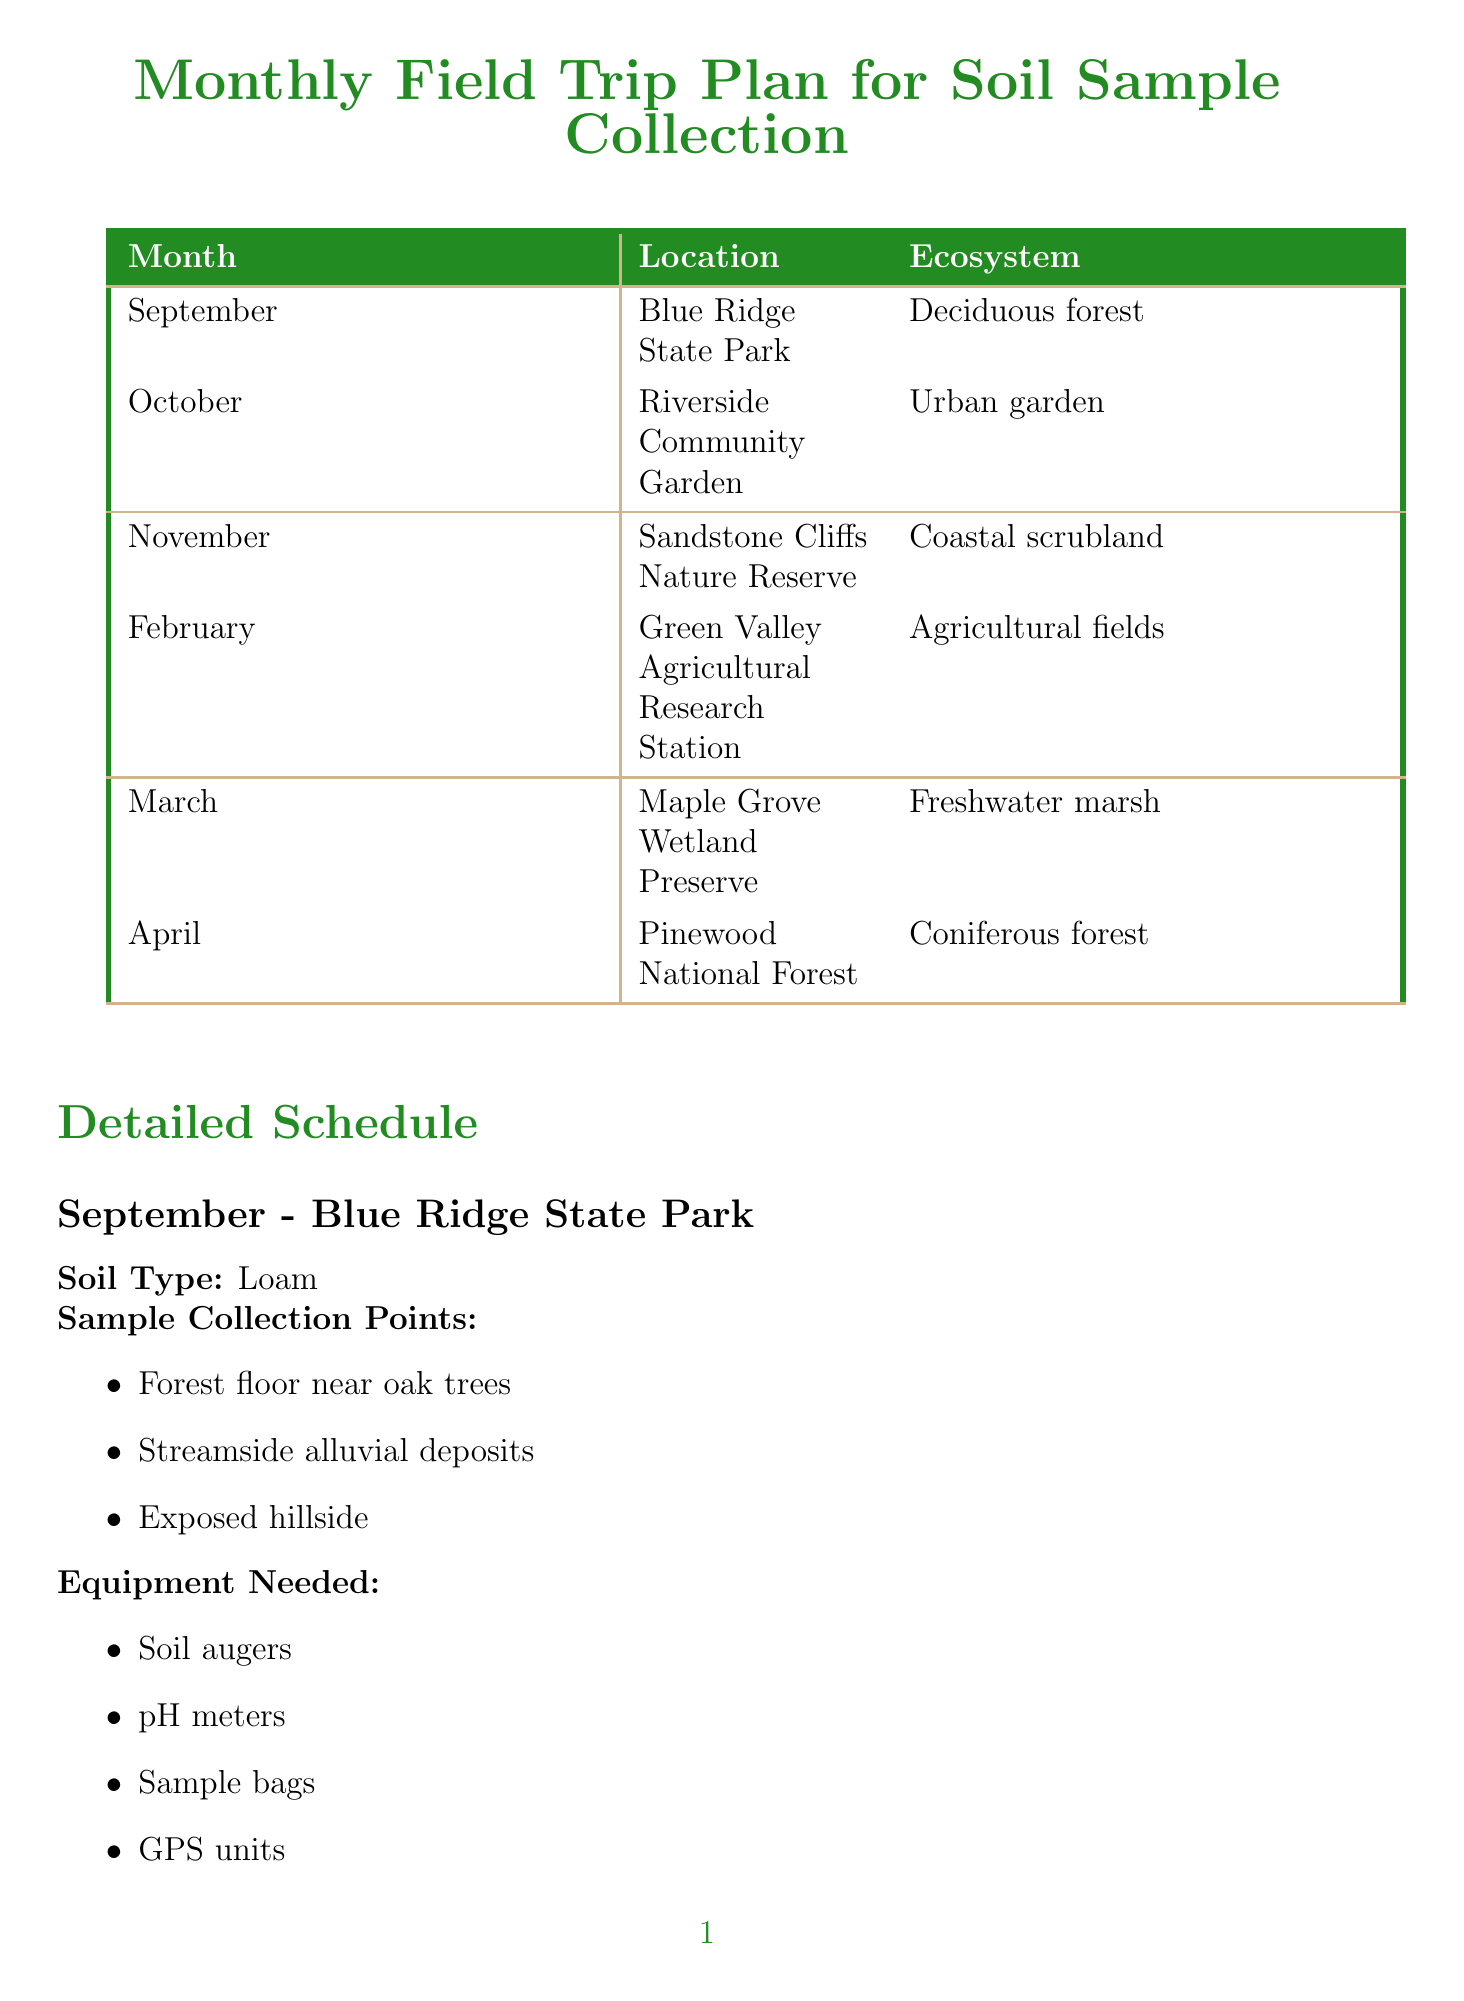What is the first field trip location? The first field trip in the schedule is listed for September at Blue Ridge State Park.
Answer: Blue Ridge State Park What type of soil is collected in October? In October, the soil type listed is clay-loam for the Riverside Community Garden.
Answer: Clay-loam How many sample collection points are there for the March field trip? The March field trip has three sample collection points listed for the Maple Grove Wetland Preserve.
Answer: 3 What is one equipment needed for the November trip? The November trip specifies core samplers as one piece of equipment needed for Sandstone Cliffs Nature Reserve.
Answer: Core samplers What is one learning objective for the April field trip? One learning objective for the April trip is to analyze soil acidity and its effects on nutrient availability in Pinewood National Forest.
Answer: Analyze soil acidity Which ecosystem is associated with the February field trip? The February field trip takes place in an agricultural field ecosystem at the Green Valley Agricultural Research Station.
Answer: Agricultural fields What is the last field trip month listed? The last month listed for a field trip in the schedule is April.
Answer: April How many trips focus on urban environments? There is one trip that focuses on an urban environment, which is in October.
Answer: 1 